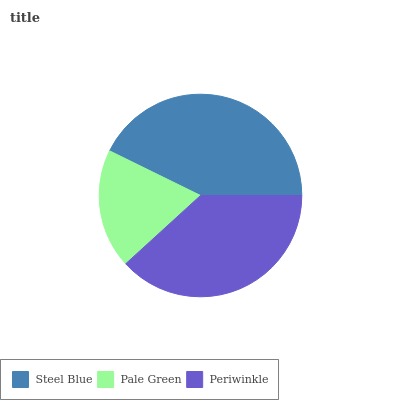Is Pale Green the minimum?
Answer yes or no. Yes. Is Steel Blue the maximum?
Answer yes or no. Yes. Is Periwinkle the minimum?
Answer yes or no. No. Is Periwinkle the maximum?
Answer yes or no. No. Is Periwinkle greater than Pale Green?
Answer yes or no. Yes. Is Pale Green less than Periwinkle?
Answer yes or no. Yes. Is Pale Green greater than Periwinkle?
Answer yes or no. No. Is Periwinkle less than Pale Green?
Answer yes or no. No. Is Periwinkle the high median?
Answer yes or no. Yes. Is Periwinkle the low median?
Answer yes or no. Yes. Is Pale Green the high median?
Answer yes or no. No. Is Steel Blue the low median?
Answer yes or no. No. 